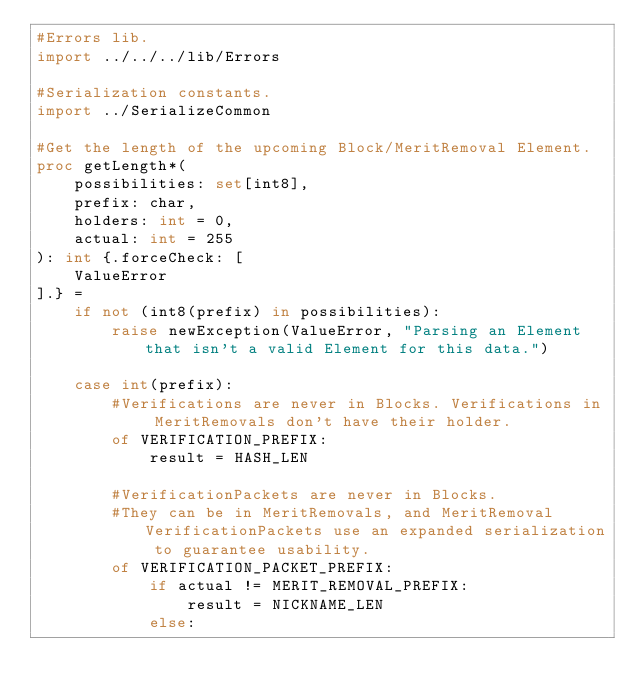Convert code to text. <code><loc_0><loc_0><loc_500><loc_500><_Nim_>#Errors lib.
import ../../../lib/Errors

#Serialization constants.
import ../SerializeCommon

#Get the length of the upcoming Block/MeritRemoval Element.
proc getLength*(
    possibilities: set[int8],
    prefix: char,
    holders: int = 0,
    actual: int = 255
): int {.forceCheck: [
    ValueError
].} =
    if not (int8(prefix) in possibilities):
        raise newException(ValueError, "Parsing an Element that isn't a valid Element for this data.")

    case int(prefix):
        #Verifications are never in Blocks. Verifications in MeritRemovals don't have their holder.
        of VERIFICATION_PREFIX:
            result = HASH_LEN

        #VerificationPackets are never in Blocks.
        #They can be in MeritRemovals, and MeritRemoval VerificationPackets use an expanded serialization to guarantee usability.
        of VERIFICATION_PACKET_PREFIX:
            if actual != MERIT_REMOVAL_PREFIX:
                result = NICKNAME_LEN
            else:</code> 